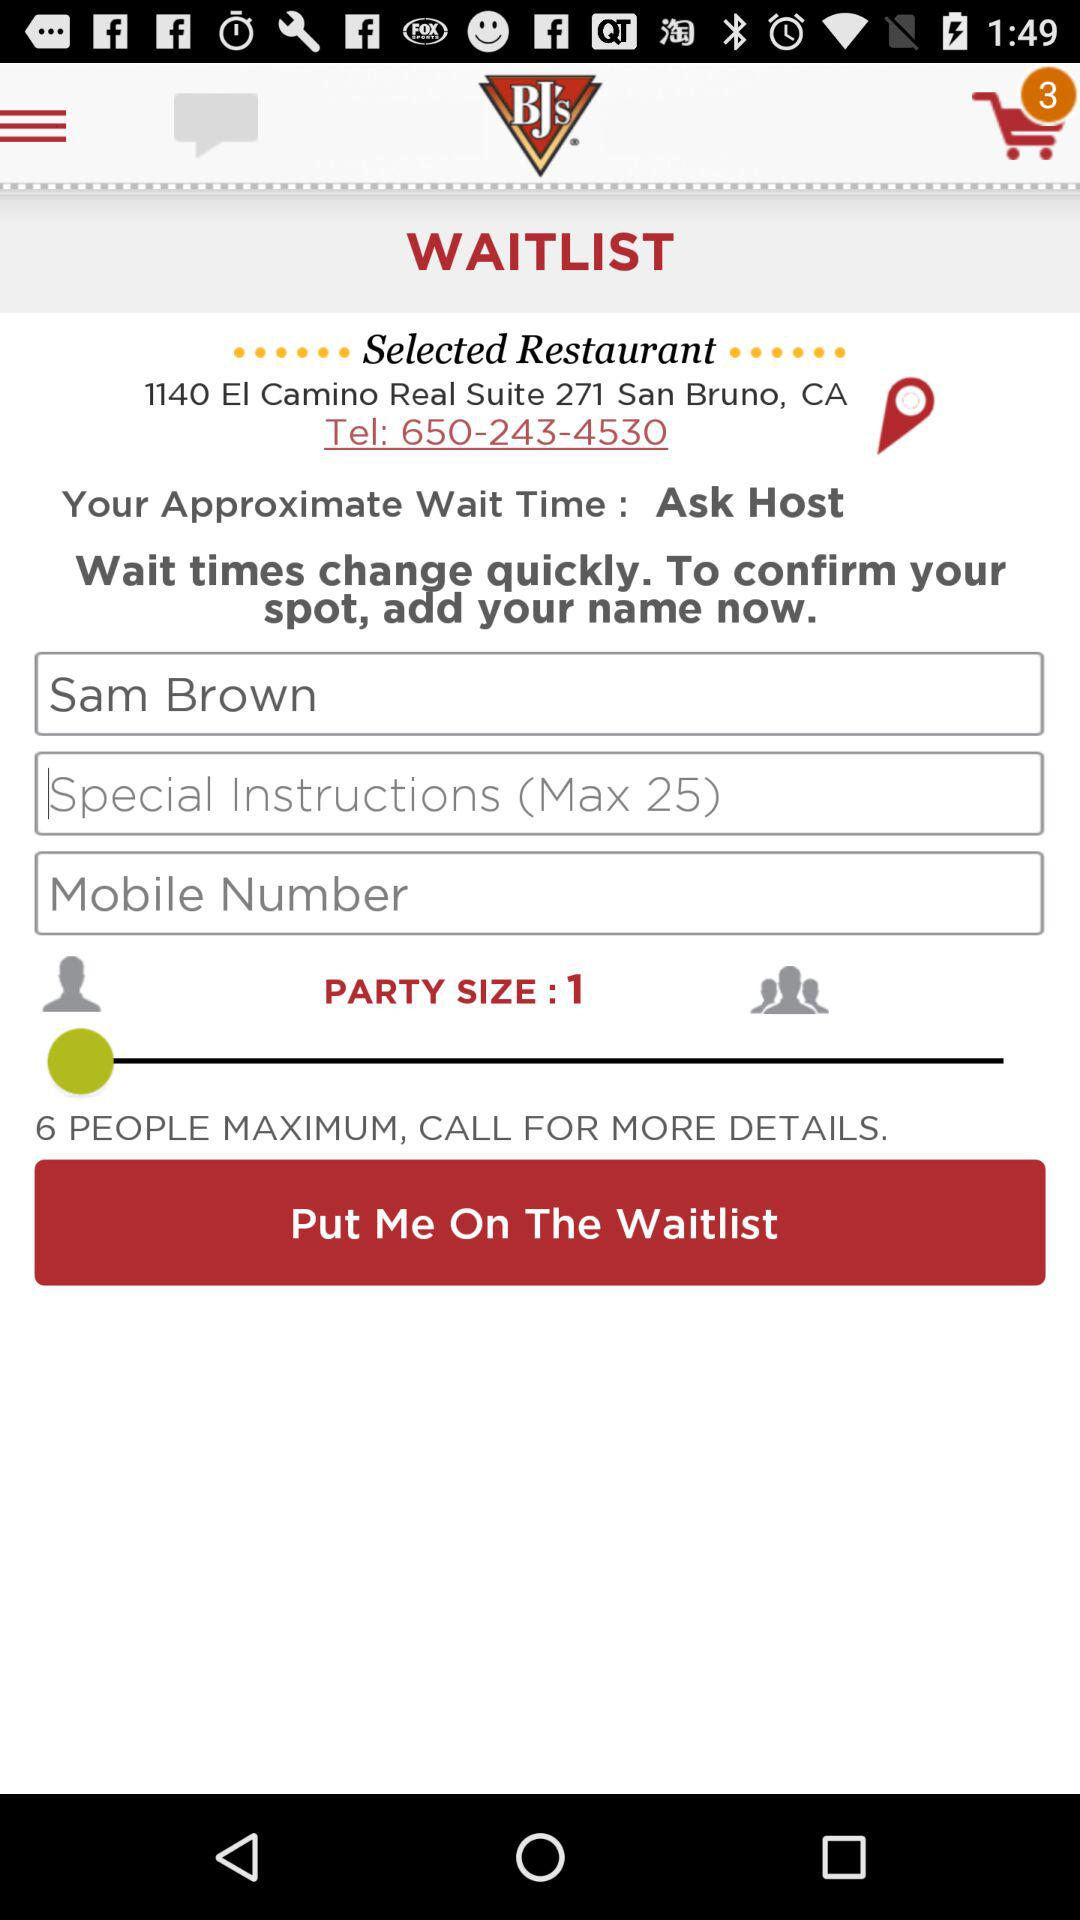How many items are in the cart? There are 3 items in the cart. 